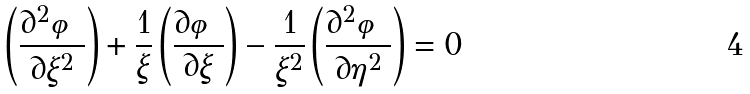Convert formula to latex. <formula><loc_0><loc_0><loc_500><loc_500>\left ( \frac { \partial ^ { 2 } \varphi } { \partial \xi ^ { 2 } } \right ) + \frac { 1 } { \xi } \left ( \frac { \partial \varphi } { \partial \xi } \right ) - \frac { 1 } { \xi ^ { 2 } } \left ( \frac { \partial ^ { 2 } \varphi } { \partial \eta ^ { 2 } } \right ) = 0</formula> 